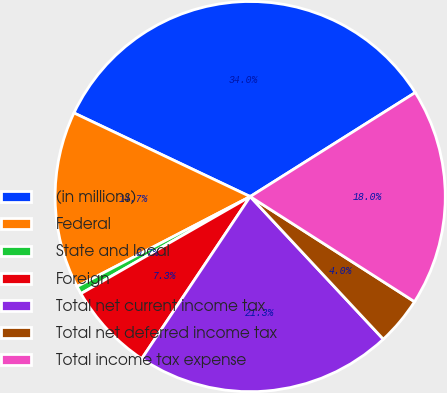<chart> <loc_0><loc_0><loc_500><loc_500><pie_chart><fcel>(in millions)<fcel>Federal<fcel>State and local<fcel>Foreign<fcel>Total net current income tax<fcel>Total net deferred income tax<fcel>Total income tax expense<nl><fcel>34.0%<fcel>14.68%<fcel>0.66%<fcel>7.33%<fcel>21.34%<fcel>3.99%<fcel>18.01%<nl></chart> 